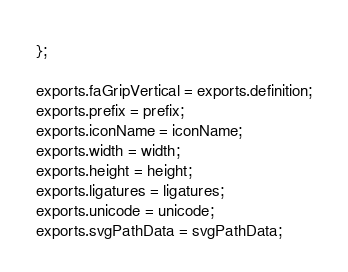Convert code to text. <code><loc_0><loc_0><loc_500><loc_500><_JavaScript_>};

exports.faGripVertical = exports.definition;
exports.prefix = prefix;
exports.iconName = iconName;
exports.width = width;
exports.height = height;
exports.ligatures = ligatures;
exports.unicode = unicode;
exports.svgPathData = svgPathData;
</code> 